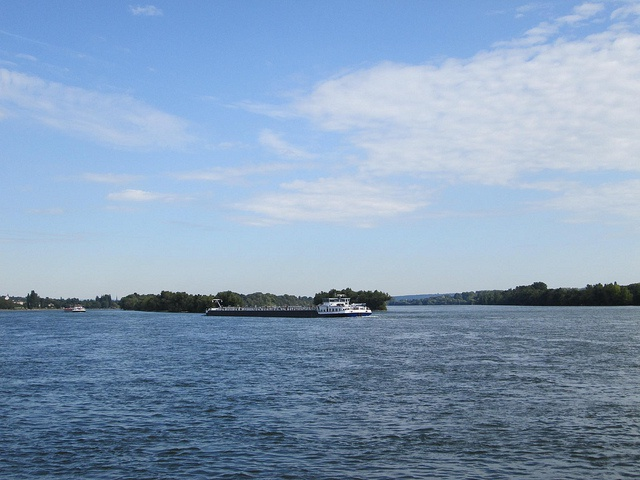Describe the objects in this image and their specific colors. I can see boat in darkgray, black, gray, and lightgray tones, boat in black, gray, darkblue, and darkgray tones, boat in darkgray, gray, and purple tones, and boat in darkgray, gray, blue, and purple tones in this image. 